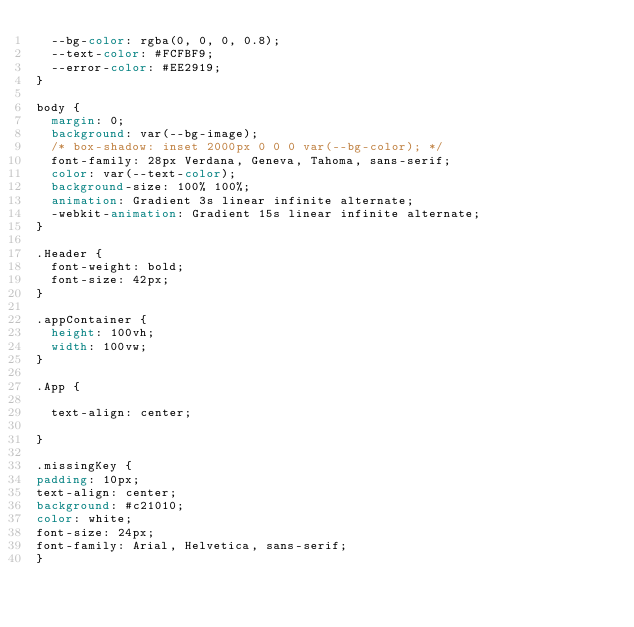Convert code to text. <code><loc_0><loc_0><loc_500><loc_500><_CSS_>  --bg-color: rgba(0, 0, 0, 0.8);
  --text-color: #FCFBF9;
  --error-color: #EE2919;
}

body {
  margin: 0;
  background: var(--bg-image);
  /* box-shadow: inset 2000px 0 0 0 var(--bg-color); */
  font-family: 28px Verdana, Geneva, Tahoma, sans-serif;
  color: var(--text-color);
  background-size: 100% 100%;
  animation: Gradient 3s linear infinite alternate;
  -webkit-animation: Gradient 15s linear infinite alternate;
}

.Header {
  font-weight: bold;
  font-size: 42px;
}

.appContainer {
  height: 100vh;
  width: 100vw;
}

.App {
  
  text-align: center;

}

.missingKey {
padding: 10px;
text-align: center;
background: #c21010;
color: white;
font-size: 24px;
font-family: Arial, Helvetica, sans-serif;
}
</code> 